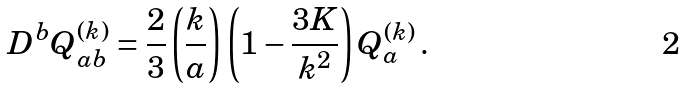<formula> <loc_0><loc_0><loc_500><loc_500>D ^ { b } Q _ { a b } ^ { ( k ) } = \frac { 2 } { 3 } \left ( \frac { k } { a } \right ) \left ( 1 - \frac { 3 K } { k ^ { 2 } } \right ) Q _ { a } ^ { ( k ) } \, .</formula> 